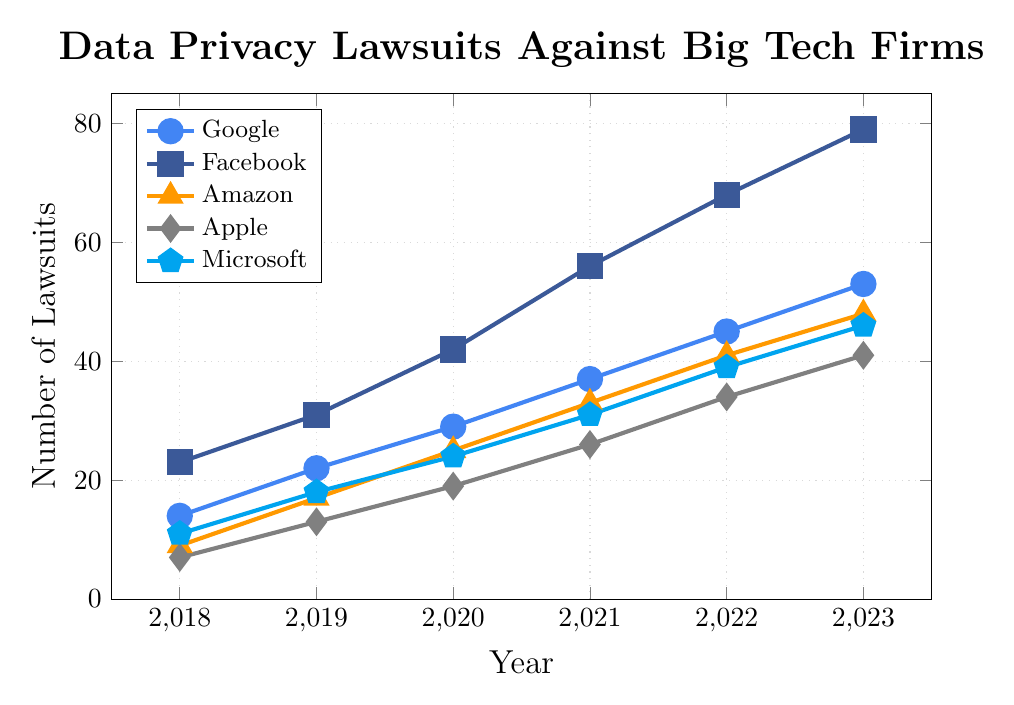What's the total number of data privacy lawsuits filed against these five companies in 2020? Sum the number of lawsuits for each company in 2020: Google (29), Facebook (42), Amazon (25), Apple (19), Microsoft (24). The total is 29 + 42 + 25 + 19 + 24 = 139.
Answer: 139 Which company had the highest number of data privacy lawsuits filed against it in 2021? Compare the number of lawsuits for each company in 2021: Google (37), Facebook (56), Amazon (33), Apple (26), Microsoft (31). Facebook had the highest with 56.
Answer: Facebook By how much did the number of lawsuits filed against Amazon increase from 2018 to 2023? Subtract the number of lawsuits in 2018 from the number in 2023 for Amazon: 48 - 9 = 39.
Answer: 39 Which companies had fewer than 20 lawsuits filed against them in 2018? Compare the number of lawsuits for each company in 2018: Google (14), Facebook (23), Amazon (9), Apple (7), Microsoft (11). Companies with fewer than 20 are Google, Amazon, Apple, and Microsoft.
Answer: Google, Amazon, Apple, Microsoft What is the average number of lawsuits filed against Microsoft per year over this period? Add the number of lawsuits for Microsoft over all years and divide by the number of years: (11 + 18 + 24 + 31 + 39 + 46) / 6 = 169 / 6 ≈ 28.17.
Answer: 28.17 Which year saw the largest increase in the number of lawsuits filed against Facebook compared to the previous year? Calculate the yearly increases for Facebook: 2019-2018 = 31 - 23 = 8, 2020-2019 = 42 - 31 = 11, 2021-2020 = 56 - 42 = 14, 2022-2021 = 68 - 56 = 12, 2023-2022 = 79 - 68 = 11. The largest increase was 14 in 2021.
Answer: 2021 Which company had the most consistent increase in lawsuits year over year? Evaluate the data for consistency. Google increases by 8, 7, 8, 8, 8. Facebook varies more. Amazon's increases are not consistent. Apple's increases are about the same. Microsoft's increases vary slightly. Google shows the most consistent pattern.
Answer: Google By what percentage did the number of lawsuits against Apple increase from 2020 to 2021? Calculate the percentage increase, (26 - 19) / 19 * 100% = 7 / 19 * 100% ≈ 36.84%.
Answer: 36.84% How does the trend of lawsuits against Amazon compare with that of Microsoft? Compare the numbers for each year side-by-side and observe the general trend. Both show an increasing trend, but Amazon's total increase is slightly larger over the span of 2018 to 2023.
Answer: Both increase steadily; Amazon increases more 